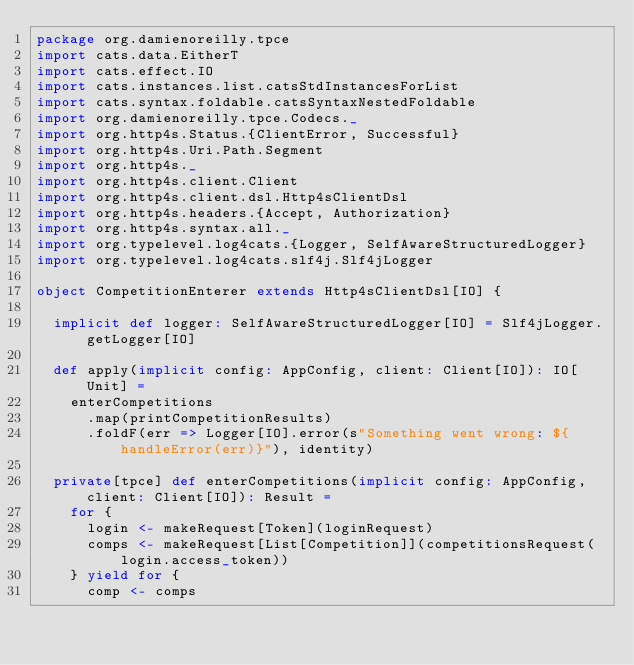<code> <loc_0><loc_0><loc_500><loc_500><_Scala_>package org.damienoreilly.tpce
import cats.data.EitherT
import cats.effect.IO
import cats.instances.list.catsStdInstancesForList
import cats.syntax.foldable.catsSyntaxNestedFoldable
import org.damienoreilly.tpce.Codecs._
import org.http4s.Status.{ClientError, Successful}
import org.http4s.Uri.Path.Segment
import org.http4s._
import org.http4s.client.Client
import org.http4s.client.dsl.Http4sClientDsl
import org.http4s.headers.{Accept, Authorization}
import org.http4s.syntax.all._
import org.typelevel.log4cats.{Logger, SelfAwareStructuredLogger}
import org.typelevel.log4cats.slf4j.Slf4jLogger

object CompetitionEnterer extends Http4sClientDsl[IO] {

  implicit def logger: SelfAwareStructuredLogger[IO] = Slf4jLogger.getLogger[IO]

  def apply(implicit config: AppConfig, client: Client[IO]): IO[Unit] =
    enterCompetitions
      .map(printCompetitionResults)
      .foldF(err => Logger[IO].error(s"Something went wrong: ${handleError(err)}"), identity)

  private[tpce] def enterCompetitions(implicit config: AppConfig, client: Client[IO]): Result =
    for {
      login <- makeRequest[Token](loginRequest)
      comps <- makeRequest[List[Competition]](competitionsRequest(login.access_token))
    } yield for {
      comp <- comps</code> 